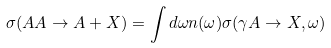<formula> <loc_0><loc_0><loc_500><loc_500>\sigma ( A A \rightarrow A + X ) = \int d \omega n ( \omega ) \sigma ( \gamma A \rightarrow X , \omega )</formula> 